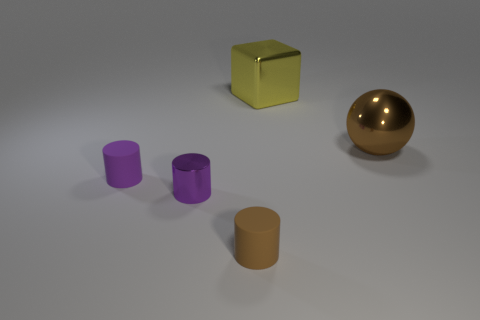There is a tiny matte thing that is in front of the tiny purple thing that is on the right side of the tiny rubber cylinder to the left of the purple metal cylinder; what color is it?
Ensure brevity in your answer.  Brown. There is a metallic object on the left side of the shiny cube; is its shape the same as the brown object that is to the left of the big yellow thing?
Offer a terse response. Yes. How many shiny cylinders are there?
Your response must be concise. 1. There is a metallic object that is the same size as the brown ball; what is its color?
Your response must be concise. Yellow. Is the brown thing on the right side of the brown matte cylinder made of the same material as the brown thing to the left of the large shiny block?
Ensure brevity in your answer.  No. How big is the brown thing in front of the big metallic object in front of the big shiny cube?
Give a very brief answer. Small. What material is the brown thing that is in front of the big metallic ball?
Provide a succinct answer. Rubber. How many objects are rubber objects that are to the left of the small purple metal object or objects that are on the left side of the shiny block?
Your response must be concise. 3. What material is the other tiny purple object that is the same shape as the small purple rubber thing?
Offer a very short reply. Metal. Do the large metal object that is in front of the big yellow cube and the tiny object that is in front of the small purple metal cylinder have the same color?
Ensure brevity in your answer.  Yes. 